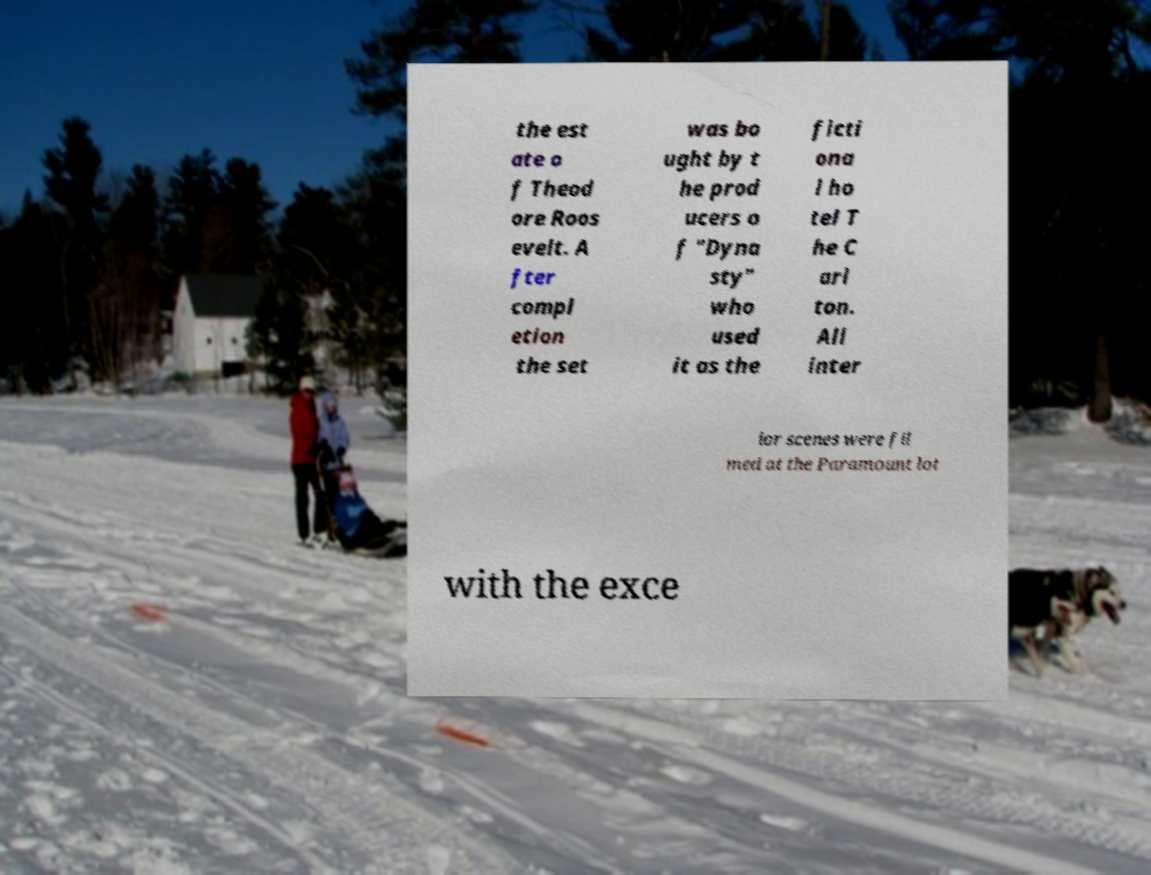Could you extract and type out the text from this image? the est ate o f Theod ore Roos evelt. A fter compl etion the set was bo ught by t he prod ucers o f "Dyna sty" who used it as the ficti ona l ho tel T he C arl ton. All inter ior scenes were fil med at the Paramount lot with the exce 